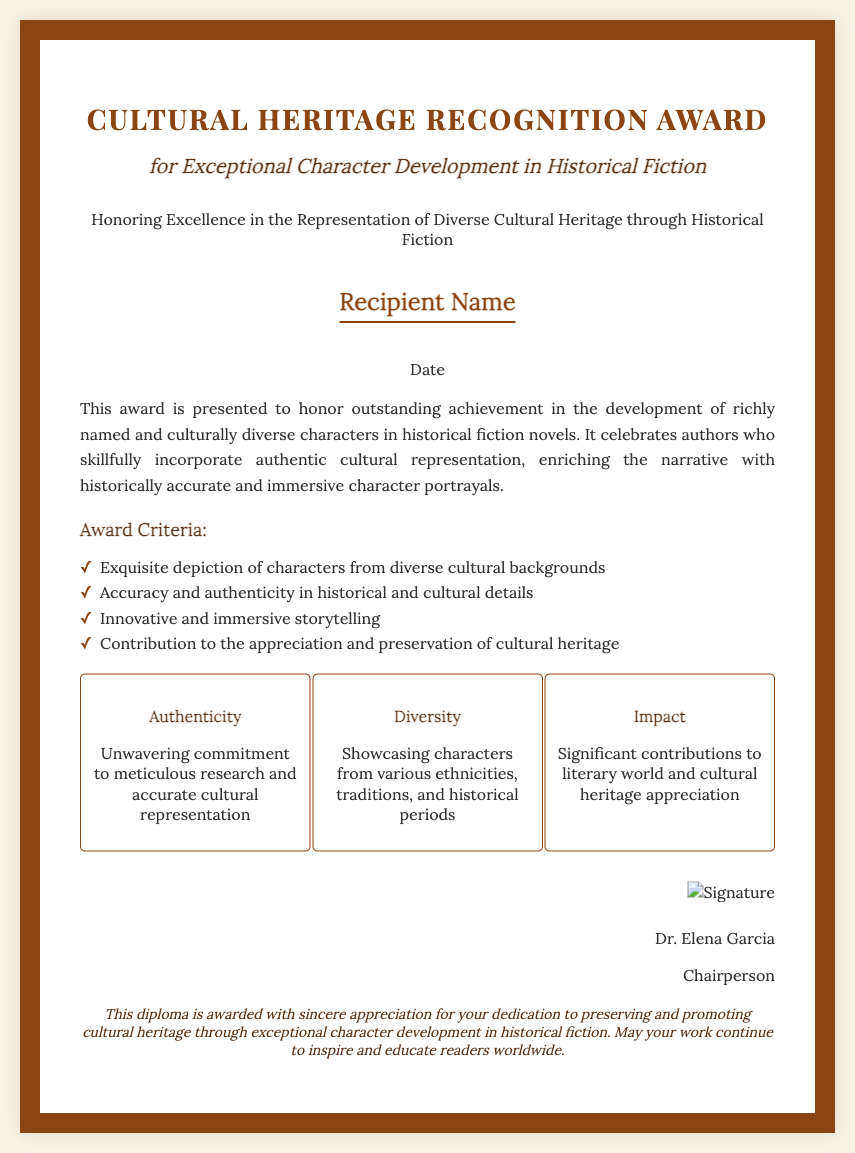What is the title of the award? The title of the award is stated prominently at the top of the document.
Answer: Cultural Heritage Recognition Award Who is the recipient of the award? The name placeholder indicates where the recipient's name would be displayed.
Answer: Recipient Name What is the date of the award? The date placeholder shows where the date will be mentioned in the document.
Answer: Date What is one of the criteria for the award? The document lists several criteria for the award; one example can be directly referenced.
Answer: Exquisite depiction of characters from diverse cultural backgrounds Who is the chairperson of the award committee? The signature area of the document identifies the chairperson's name.
Answer: Dr. Elena Garcia What is one feature highlighted in the award? The features section lists aspects of the award, focusing on key characteristics.
Answer: Authenticity How does the award contribute to literature? The award recognizes exceptional character development that fosters cultural appreciation.
Answer: Significant contributions to literary world and cultural heritage appreciation What type of document is this? The format and content make it clear that this document serves a specific recognition purpose.
Answer: Diploma What is the purpose of this award? The introductory paragraph summarizes the intention behind presenting this award.
Answer: Honoring Excellence in the Representation of Diverse Cultural Heritage through Historical Fiction 